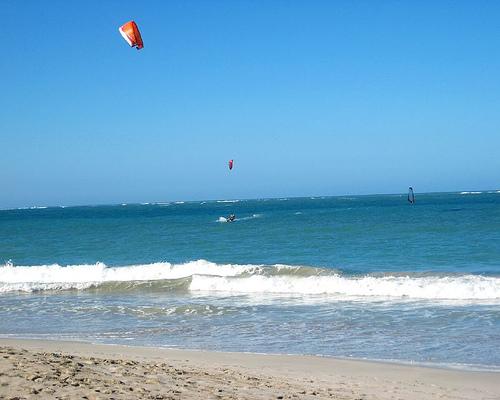What kind of boat is in the distance?
Answer briefly. Sailboat. Could this be parasailing?
Keep it brief. Yes. Does the Ocean touch the sky?
Give a very brief answer. No. 